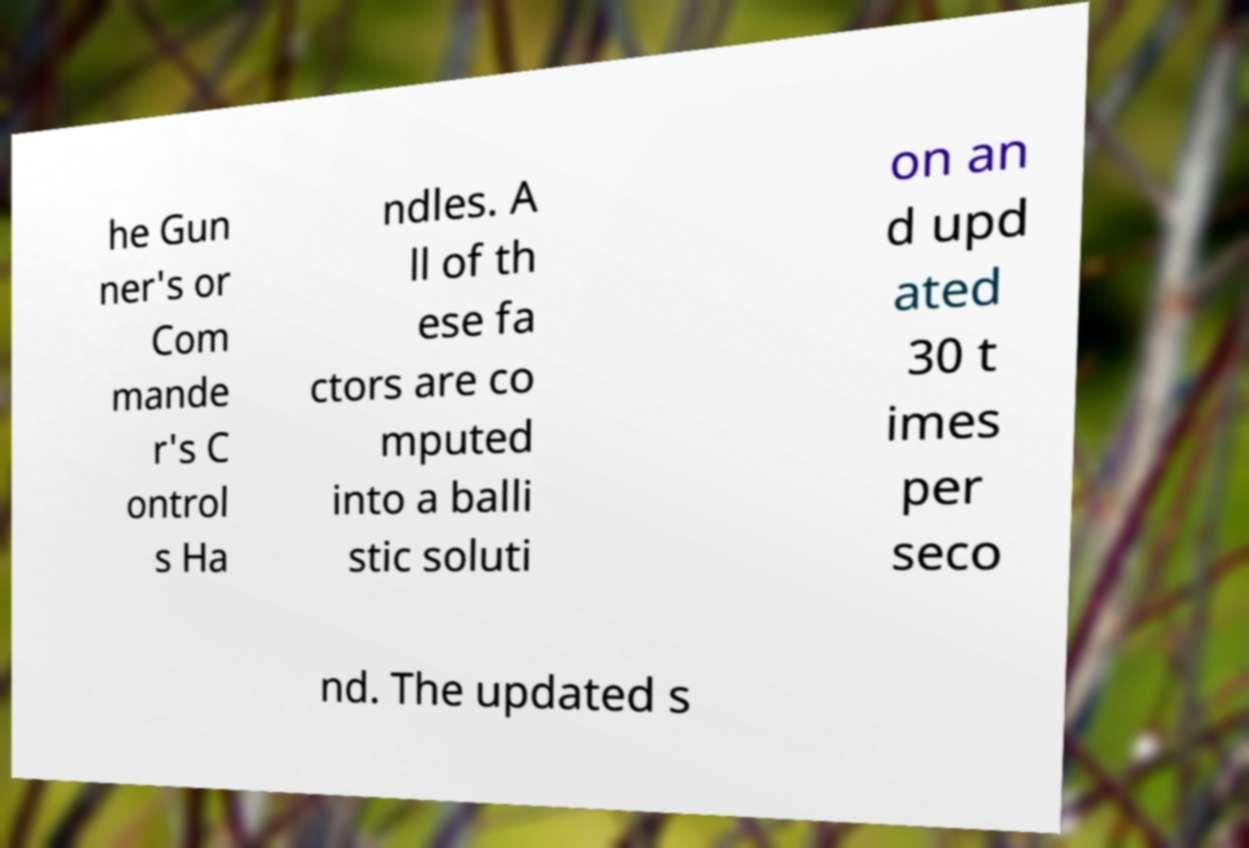Please identify and transcribe the text found in this image. he Gun ner's or Com mande r's C ontrol s Ha ndles. A ll of th ese fa ctors are co mputed into a balli stic soluti on an d upd ated 30 t imes per seco nd. The updated s 